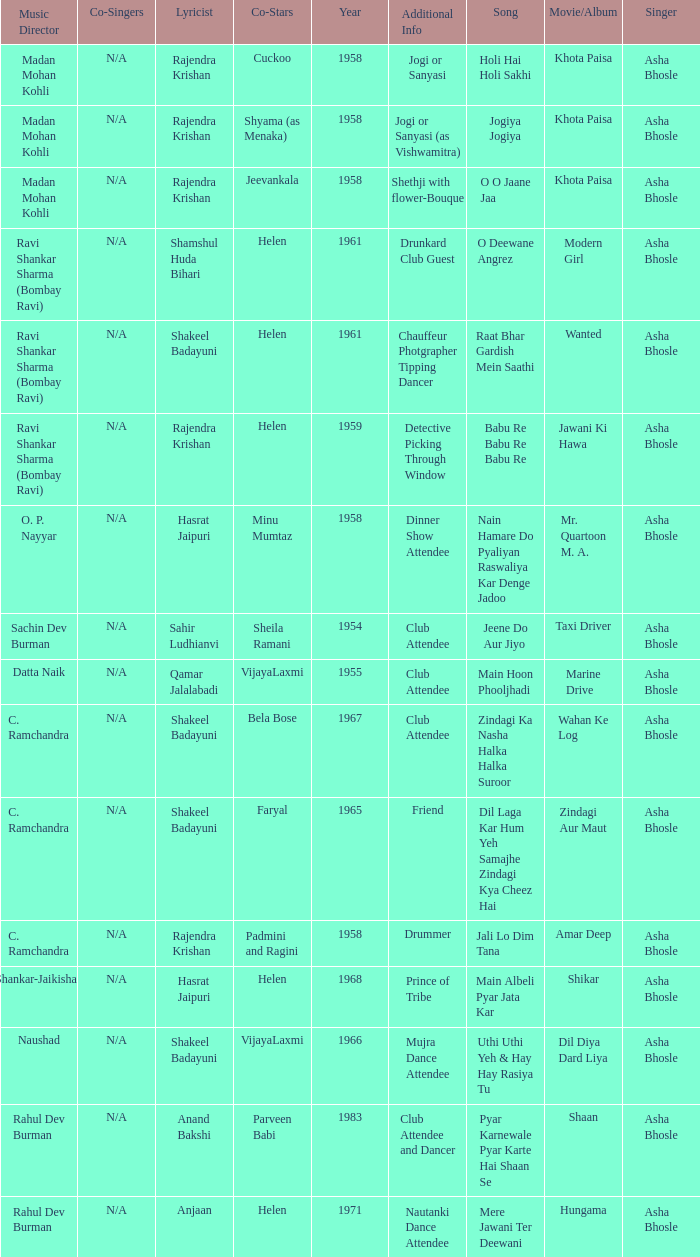What movie did Bela Bose co-star in? Wahan Ke Log. 